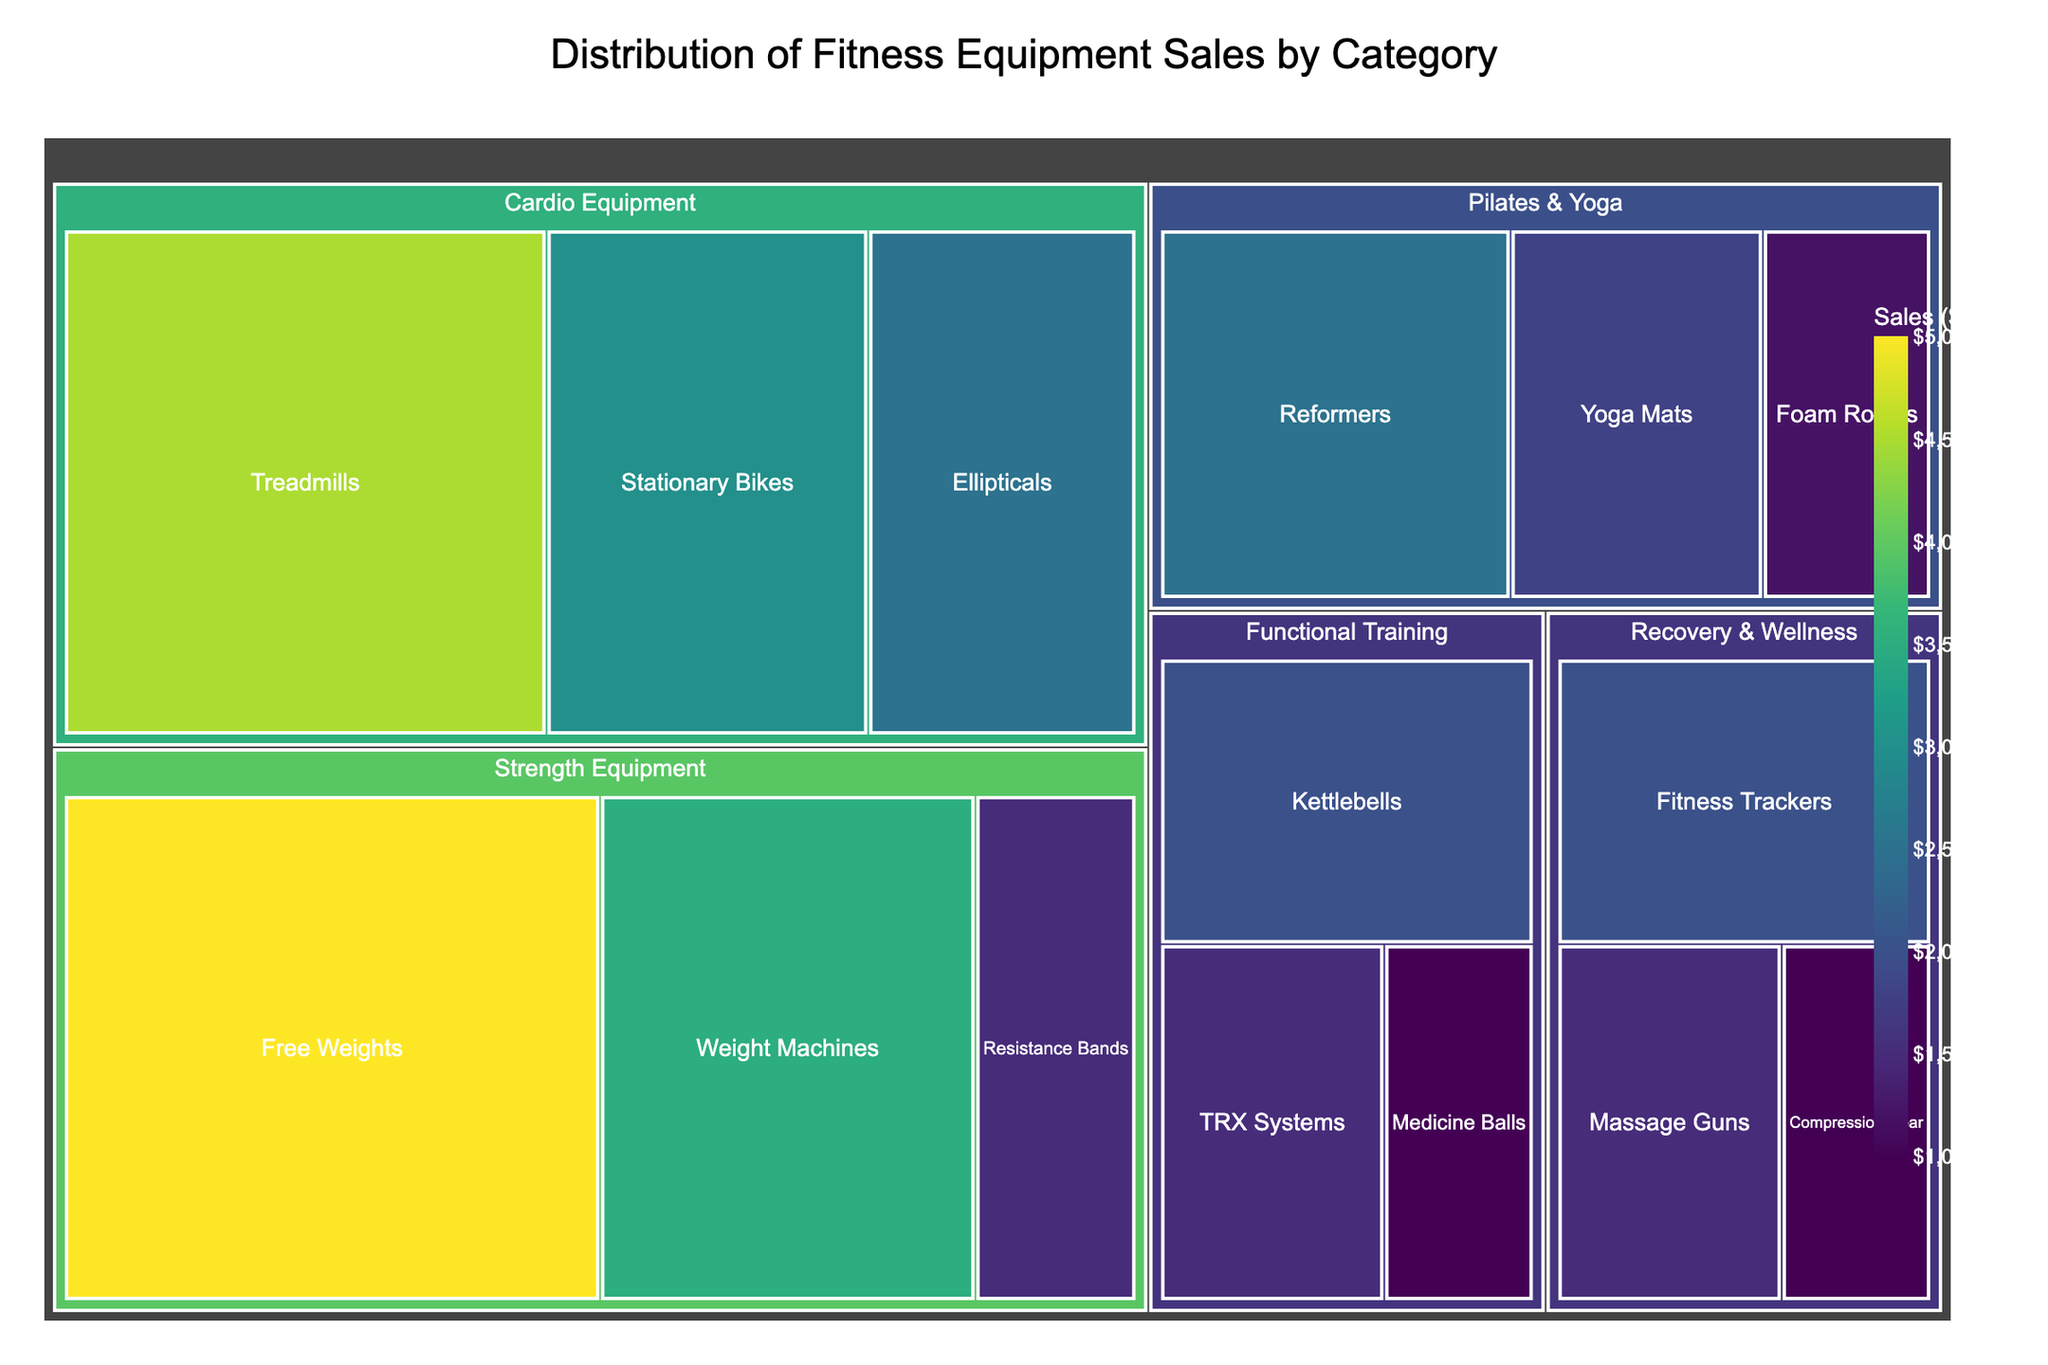What is the title of the figure? The title is usually at the top of the figure and reads "Distribution of Fitness Equipment Sales by Category."
Answer: Distribution of Fitness Equipment Sales by Category Which category has the highest total sales? To determine the highest total sales, sum the sales of the subcategories within each main category. From the figure, visually identify the category with the largest block size, which is "Strength Equipment."
Answer: Strength Equipment How much did sales for 'Treadmills' amount to? Locate 'Treadmills' under 'Cardio Equipment' and note the sales amount displayed.
Answer: $4,500,000 How many subcategories are there in 'Pilates & Yoga'? Count the distinct subcategories under 'Pilates & Yoga.' The figure shows Reformers, Yoga Mats, and Foam Rollers.
Answer: 3 Which subcategory in 'Recovery & Wellness' has the lowest sales? Identify the subcategory with the smallest block size in 'Recovery & Wellness,' which would be 'Compression Gear.'
Answer: Compression Gear What are the sales values for 'Resistance Bands' and 'Fitness Trackers'? Identify and note the sales values for 'Resistance Bands' and 'Fitness Trackers' in the figure.
Answer: Resistance Bands: $1,500,000; Fitness Trackers: $2,000,000 What is the total sales figure for 'Cardio Equipment'? Sum the sales of all subcategories under 'Cardio Equipment' (Treadmills: $4,500,000, Stationary Bikes: $3,000,000, Ellipticals: $2,500,000).
Answer: $10,000,000 Which has higher sales: 'Kettlebells' or 'Foam Rollers'? Compare the sales values for 'Kettlebells' in Functional Training ($2,000,000) and 'Foam Rollers' in Pilates & Yoga ($1,200,000).
Answer: Kettlebells What is the average sales value of the subcategories in 'Functional Training'? Add the sales of all subcategories in 'Functional Training' and divide by the number of subcategories (Kettlebells: $2,000,000, Medicine Balls: $1,000,000, TRX Systems: $1,500,000). The total is $4,500,000, and there are 3 subcategories.
Answer: $1,500,000 Which subcategory in 'Strength Equipment' has the highest sales? Identify the subcategory with the largest block size under 'Strength Equipment,' which is 'Free Weights.'
Answer: Free Weights 